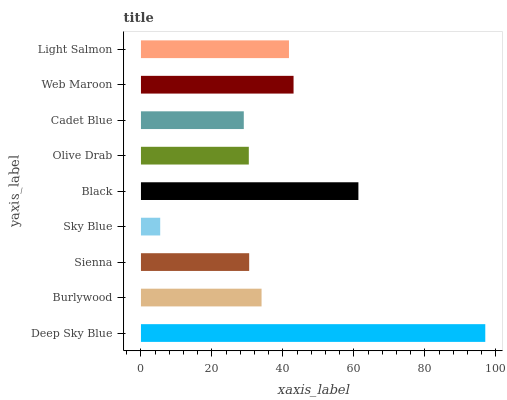Is Sky Blue the minimum?
Answer yes or no. Yes. Is Deep Sky Blue the maximum?
Answer yes or no. Yes. Is Burlywood the minimum?
Answer yes or no. No. Is Burlywood the maximum?
Answer yes or no. No. Is Deep Sky Blue greater than Burlywood?
Answer yes or no. Yes. Is Burlywood less than Deep Sky Blue?
Answer yes or no. Yes. Is Burlywood greater than Deep Sky Blue?
Answer yes or no. No. Is Deep Sky Blue less than Burlywood?
Answer yes or no. No. Is Burlywood the high median?
Answer yes or no. Yes. Is Burlywood the low median?
Answer yes or no. Yes. Is Sky Blue the high median?
Answer yes or no. No. Is Olive Drab the low median?
Answer yes or no. No. 